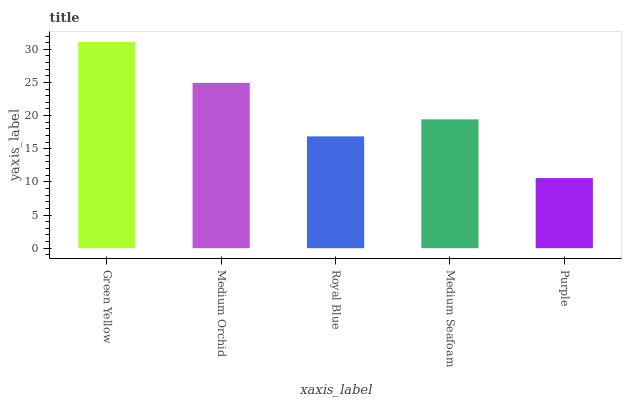Is Purple the minimum?
Answer yes or no. Yes. Is Green Yellow the maximum?
Answer yes or no. Yes. Is Medium Orchid the minimum?
Answer yes or no. No. Is Medium Orchid the maximum?
Answer yes or no. No. Is Green Yellow greater than Medium Orchid?
Answer yes or no. Yes. Is Medium Orchid less than Green Yellow?
Answer yes or no. Yes. Is Medium Orchid greater than Green Yellow?
Answer yes or no. No. Is Green Yellow less than Medium Orchid?
Answer yes or no. No. Is Medium Seafoam the high median?
Answer yes or no. Yes. Is Medium Seafoam the low median?
Answer yes or no. Yes. Is Purple the high median?
Answer yes or no. No. Is Purple the low median?
Answer yes or no. No. 